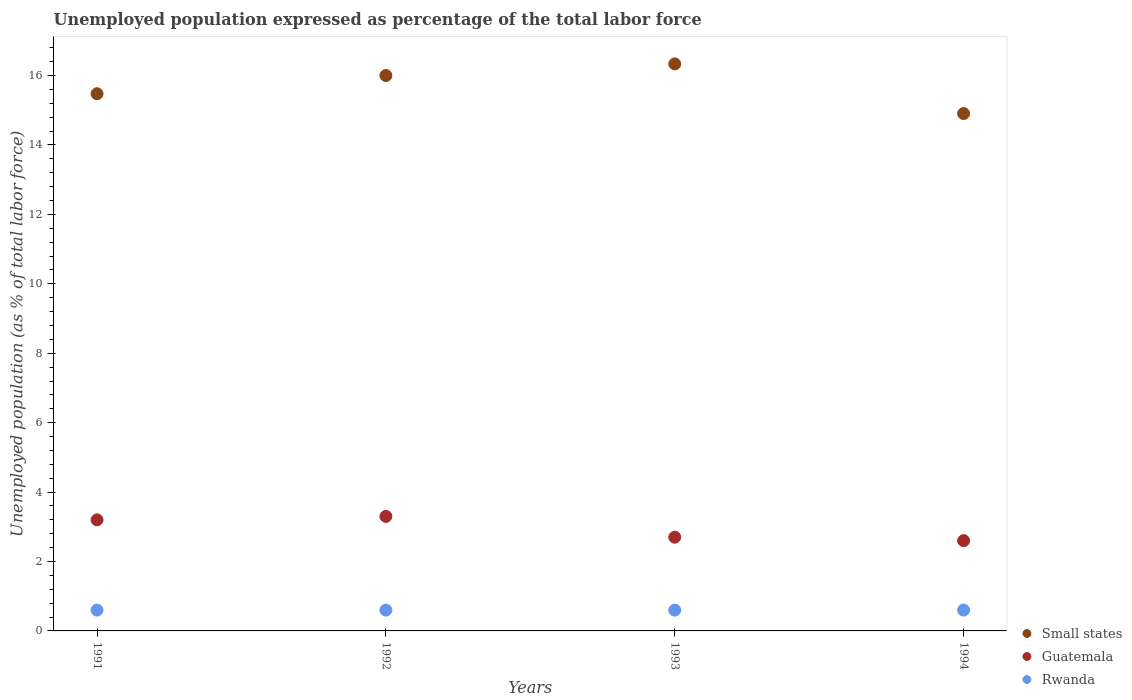What is the unemployment in in Guatemala in 1994?
Make the answer very short. 2.6. Across all years, what is the maximum unemployment in in Guatemala?
Make the answer very short. 3.3. Across all years, what is the minimum unemployment in in Guatemala?
Your answer should be compact. 2.6. In which year was the unemployment in in Guatemala maximum?
Your answer should be very brief. 1992. What is the total unemployment in in Small states in the graph?
Provide a short and direct response. 62.72. What is the difference between the unemployment in in Rwanda in 1991 and that in 1993?
Keep it short and to the point. 0. What is the difference between the unemployment in in Guatemala in 1993 and the unemployment in in Small states in 1994?
Keep it short and to the point. -12.21. What is the average unemployment in in Small states per year?
Keep it short and to the point. 15.68. In the year 1991, what is the difference between the unemployment in in Small states and unemployment in in Guatemala?
Provide a short and direct response. 12.28. Is the unemployment in in Rwanda in 1991 less than that in 1994?
Keep it short and to the point. No. What is the difference between the highest and the second highest unemployment in in Small states?
Your answer should be compact. 0.34. Is the sum of the unemployment in in Guatemala in 1991 and 1993 greater than the maximum unemployment in in Rwanda across all years?
Offer a terse response. Yes. Is it the case that in every year, the sum of the unemployment in in Rwanda and unemployment in in Guatemala  is greater than the unemployment in in Small states?
Your response must be concise. No. Is the unemployment in in Guatemala strictly less than the unemployment in in Rwanda over the years?
Your answer should be compact. No. How many dotlines are there?
Your response must be concise. 3. How many years are there in the graph?
Your response must be concise. 4. What is the difference between two consecutive major ticks on the Y-axis?
Give a very brief answer. 2. Are the values on the major ticks of Y-axis written in scientific E-notation?
Ensure brevity in your answer.  No. How many legend labels are there?
Give a very brief answer. 3. What is the title of the graph?
Offer a terse response. Unemployed population expressed as percentage of the total labor force. What is the label or title of the Y-axis?
Your response must be concise. Unemployed population (as % of total labor force). What is the Unemployed population (as % of total labor force) of Small states in 1991?
Your answer should be compact. 15.48. What is the Unemployed population (as % of total labor force) in Guatemala in 1991?
Ensure brevity in your answer.  3.2. What is the Unemployed population (as % of total labor force) of Rwanda in 1991?
Offer a terse response. 0.6. What is the Unemployed population (as % of total labor force) in Small states in 1992?
Provide a short and direct response. 16. What is the Unemployed population (as % of total labor force) of Guatemala in 1992?
Keep it short and to the point. 3.3. What is the Unemployed population (as % of total labor force) of Rwanda in 1992?
Provide a succinct answer. 0.6. What is the Unemployed population (as % of total labor force) in Small states in 1993?
Offer a terse response. 16.34. What is the Unemployed population (as % of total labor force) of Guatemala in 1993?
Your response must be concise. 2.7. What is the Unemployed population (as % of total labor force) in Rwanda in 1993?
Your answer should be very brief. 0.6. What is the Unemployed population (as % of total labor force) in Small states in 1994?
Offer a terse response. 14.91. What is the Unemployed population (as % of total labor force) of Guatemala in 1994?
Offer a very short reply. 2.6. What is the Unemployed population (as % of total labor force) in Rwanda in 1994?
Ensure brevity in your answer.  0.6. Across all years, what is the maximum Unemployed population (as % of total labor force) of Small states?
Give a very brief answer. 16.34. Across all years, what is the maximum Unemployed population (as % of total labor force) in Guatemala?
Offer a terse response. 3.3. Across all years, what is the maximum Unemployed population (as % of total labor force) of Rwanda?
Offer a very short reply. 0.6. Across all years, what is the minimum Unemployed population (as % of total labor force) in Small states?
Provide a short and direct response. 14.91. Across all years, what is the minimum Unemployed population (as % of total labor force) of Guatemala?
Make the answer very short. 2.6. Across all years, what is the minimum Unemployed population (as % of total labor force) of Rwanda?
Your answer should be very brief. 0.6. What is the total Unemployed population (as % of total labor force) in Small states in the graph?
Your answer should be very brief. 62.72. What is the total Unemployed population (as % of total labor force) in Rwanda in the graph?
Offer a terse response. 2.4. What is the difference between the Unemployed population (as % of total labor force) of Small states in 1991 and that in 1992?
Provide a succinct answer. -0.52. What is the difference between the Unemployed population (as % of total labor force) of Small states in 1991 and that in 1993?
Provide a short and direct response. -0.86. What is the difference between the Unemployed population (as % of total labor force) of Rwanda in 1991 and that in 1993?
Make the answer very short. 0. What is the difference between the Unemployed population (as % of total labor force) of Small states in 1991 and that in 1994?
Make the answer very short. 0.57. What is the difference between the Unemployed population (as % of total labor force) in Small states in 1992 and that in 1993?
Provide a succinct answer. -0.34. What is the difference between the Unemployed population (as % of total labor force) of Rwanda in 1992 and that in 1993?
Provide a short and direct response. 0. What is the difference between the Unemployed population (as % of total labor force) in Small states in 1992 and that in 1994?
Offer a very short reply. 1.1. What is the difference between the Unemployed population (as % of total labor force) of Small states in 1993 and that in 1994?
Provide a short and direct response. 1.43. What is the difference between the Unemployed population (as % of total labor force) of Guatemala in 1993 and that in 1994?
Provide a succinct answer. 0.1. What is the difference between the Unemployed population (as % of total labor force) in Small states in 1991 and the Unemployed population (as % of total labor force) in Guatemala in 1992?
Provide a short and direct response. 12.18. What is the difference between the Unemployed population (as % of total labor force) in Small states in 1991 and the Unemployed population (as % of total labor force) in Rwanda in 1992?
Make the answer very short. 14.88. What is the difference between the Unemployed population (as % of total labor force) of Small states in 1991 and the Unemployed population (as % of total labor force) of Guatemala in 1993?
Ensure brevity in your answer.  12.78. What is the difference between the Unemployed population (as % of total labor force) of Small states in 1991 and the Unemployed population (as % of total labor force) of Rwanda in 1993?
Provide a succinct answer. 14.88. What is the difference between the Unemployed population (as % of total labor force) of Small states in 1991 and the Unemployed population (as % of total labor force) of Guatemala in 1994?
Ensure brevity in your answer.  12.88. What is the difference between the Unemployed population (as % of total labor force) in Small states in 1991 and the Unemployed population (as % of total labor force) in Rwanda in 1994?
Your answer should be very brief. 14.88. What is the difference between the Unemployed population (as % of total labor force) in Guatemala in 1991 and the Unemployed population (as % of total labor force) in Rwanda in 1994?
Your response must be concise. 2.6. What is the difference between the Unemployed population (as % of total labor force) in Small states in 1992 and the Unemployed population (as % of total labor force) in Guatemala in 1993?
Offer a terse response. 13.3. What is the difference between the Unemployed population (as % of total labor force) in Small states in 1992 and the Unemployed population (as % of total labor force) in Rwanda in 1993?
Your answer should be very brief. 15.4. What is the difference between the Unemployed population (as % of total labor force) of Small states in 1992 and the Unemployed population (as % of total labor force) of Guatemala in 1994?
Make the answer very short. 13.4. What is the difference between the Unemployed population (as % of total labor force) in Small states in 1992 and the Unemployed population (as % of total labor force) in Rwanda in 1994?
Provide a succinct answer. 15.4. What is the difference between the Unemployed population (as % of total labor force) of Small states in 1993 and the Unemployed population (as % of total labor force) of Guatemala in 1994?
Make the answer very short. 13.74. What is the difference between the Unemployed population (as % of total labor force) in Small states in 1993 and the Unemployed population (as % of total labor force) in Rwanda in 1994?
Keep it short and to the point. 15.74. What is the average Unemployed population (as % of total labor force) in Small states per year?
Provide a short and direct response. 15.68. What is the average Unemployed population (as % of total labor force) in Guatemala per year?
Offer a very short reply. 2.95. In the year 1991, what is the difference between the Unemployed population (as % of total labor force) in Small states and Unemployed population (as % of total labor force) in Guatemala?
Provide a succinct answer. 12.28. In the year 1991, what is the difference between the Unemployed population (as % of total labor force) of Small states and Unemployed population (as % of total labor force) of Rwanda?
Offer a terse response. 14.88. In the year 1992, what is the difference between the Unemployed population (as % of total labor force) of Small states and Unemployed population (as % of total labor force) of Guatemala?
Provide a short and direct response. 12.7. In the year 1992, what is the difference between the Unemployed population (as % of total labor force) in Small states and Unemployed population (as % of total labor force) in Rwanda?
Keep it short and to the point. 15.4. In the year 1992, what is the difference between the Unemployed population (as % of total labor force) in Guatemala and Unemployed population (as % of total labor force) in Rwanda?
Make the answer very short. 2.7. In the year 1993, what is the difference between the Unemployed population (as % of total labor force) of Small states and Unemployed population (as % of total labor force) of Guatemala?
Your answer should be compact. 13.64. In the year 1993, what is the difference between the Unemployed population (as % of total labor force) of Small states and Unemployed population (as % of total labor force) of Rwanda?
Make the answer very short. 15.74. In the year 1994, what is the difference between the Unemployed population (as % of total labor force) in Small states and Unemployed population (as % of total labor force) in Guatemala?
Offer a very short reply. 12.31. In the year 1994, what is the difference between the Unemployed population (as % of total labor force) in Small states and Unemployed population (as % of total labor force) in Rwanda?
Your answer should be very brief. 14.31. In the year 1994, what is the difference between the Unemployed population (as % of total labor force) of Guatemala and Unemployed population (as % of total labor force) of Rwanda?
Your answer should be very brief. 2. What is the ratio of the Unemployed population (as % of total labor force) of Small states in 1991 to that in 1992?
Make the answer very short. 0.97. What is the ratio of the Unemployed population (as % of total labor force) in Guatemala in 1991 to that in 1992?
Provide a succinct answer. 0.97. What is the ratio of the Unemployed population (as % of total labor force) in Guatemala in 1991 to that in 1993?
Keep it short and to the point. 1.19. What is the ratio of the Unemployed population (as % of total labor force) in Rwanda in 1991 to that in 1993?
Your answer should be very brief. 1. What is the ratio of the Unemployed population (as % of total labor force) of Small states in 1991 to that in 1994?
Make the answer very short. 1.04. What is the ratio of the Unemployed population (as % of total labor force) of Guatemala in 1991 to that in 1994?
Keep it short and to the point. 1.23. What is the ratio of the Unemployed population (as % of total labor force) of Rwanda in 1991 to that in 1994?
Provide a succinct answer. 1. What is the ratio of the Unemployed population (as % of total labor force) of Small states in 1992 to that in 1993?
Provide a short and direct response. 0.98. What is the ratio of the Unemployed population (as % of total labor force) in Guatemala in 1992 to that in 1993?
Give a very brief answer. 1.22. What is the ratio of the Unemployed population (as % of total labor force) in Small states in 1992 to that in 1994?
Ensure brevity in your answer.  1.07. What is the ratio of the Unemployed population (as % of total labor force) of Guatemala in 1992 to that in 1994?
Offer a terse response. 1.27. What is the ratio of the Unemployed population (as % of total labor force) in Small states in 1993 to that in 1994?
Give a very brief answer. 1.1. What is the difference between the highest and the second highest Unemployed population (as % of total labor force) in Small states?
Ensure brevity in your answer.  0.34. What is the difference between the highest and the second highest Unemployed population (as % of total labor force) of Rwanda?
Provide a succinct answer. 0. What is the difference between the highest and the lowest Unemployed population (as % of total labor force) of Small states?
Your answer should be compact. 1.43. What is the difference between the highest and the lowest Unemployed population (as % of total labor force) in Guatemala?
Ensure brevity in your answer.  0.7. What is the difference between the highest and the lowest Unemployed population (as % of total labor force) in Rwanda?
Offer a very short reply. 0. 